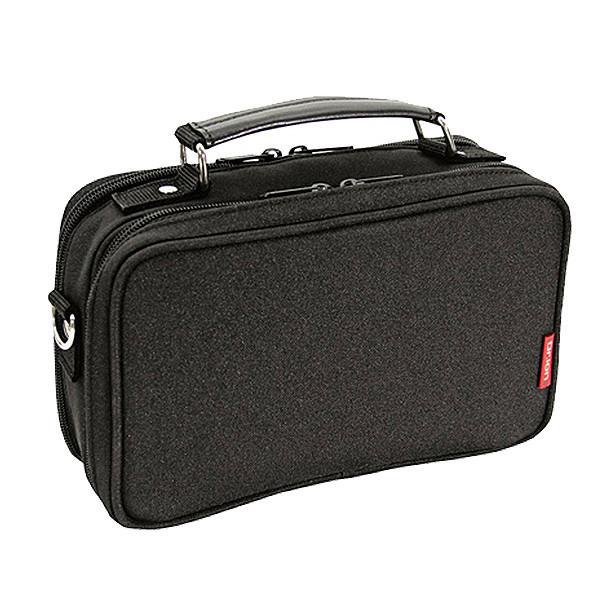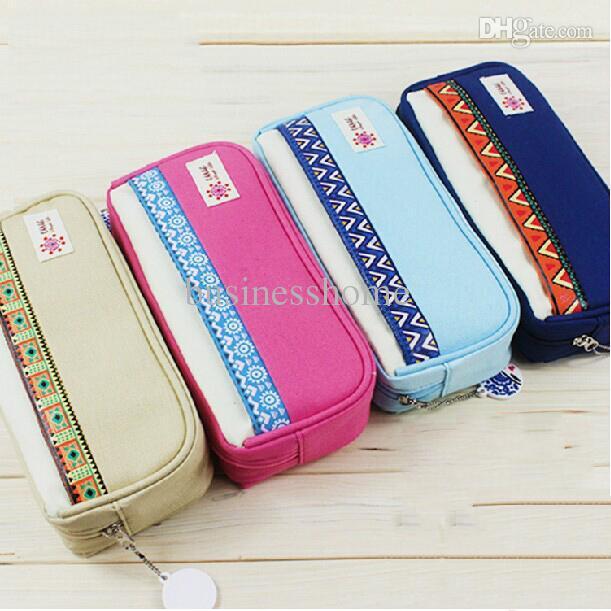The first image is the image on the left, the second image is the image on the right. Analyze the images presented: Is the assertion "At leat one container is green." valid? Answer yes or no. No. 